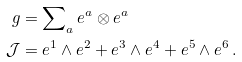<formula> <loc_0><loc_0><loc_500><loc_500>g & = \sum \nolimits _ { a } e ^ { a } \otimes e ^ { a } \\ \mathcal { J } & = e ^ { 1 } \wedge e ^ { 2 } + e ^ { 3 } \wedge e ^ { 4 } + e ^ { 5 } \wedge e ^ { 6 } \, .</formula> 